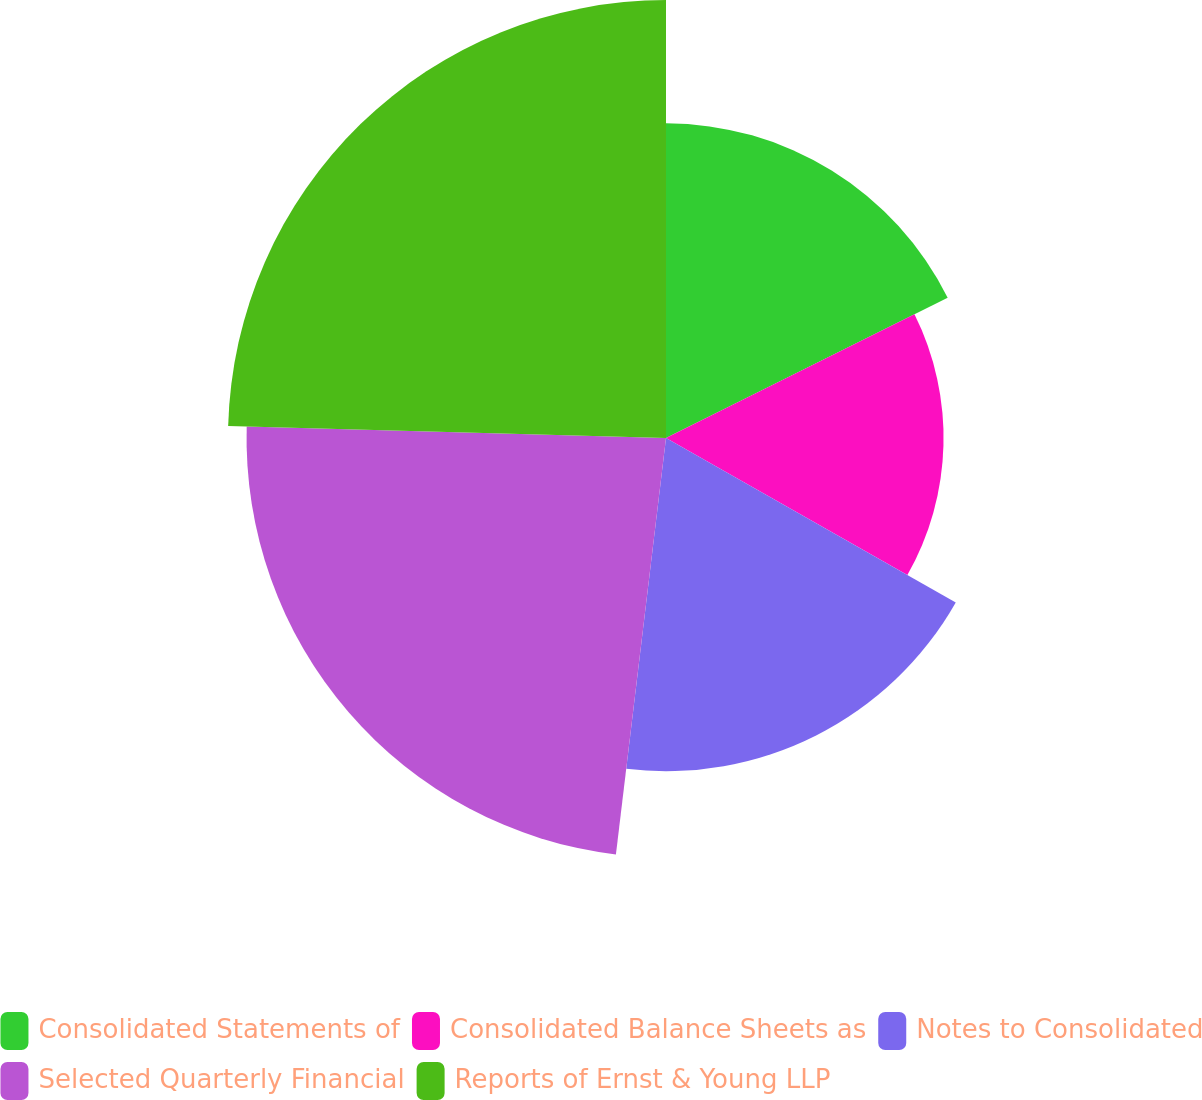Convert chart. <chart><loc_0><loc_0><loc_500><loc_500><pie_chart><fcel>Consolidated Statements of<fcel>Consolidated Balance Sheets as<fcel>Notes to Consolidated<fcel>Selected Quarterly Financial<fcel>Reports of Ernst & Young LLP<nl><fcel>17.65%<fcel>15.57%<fcel>18.69%<fcel>23.53%<fcel>24.57%<nl></chart> 